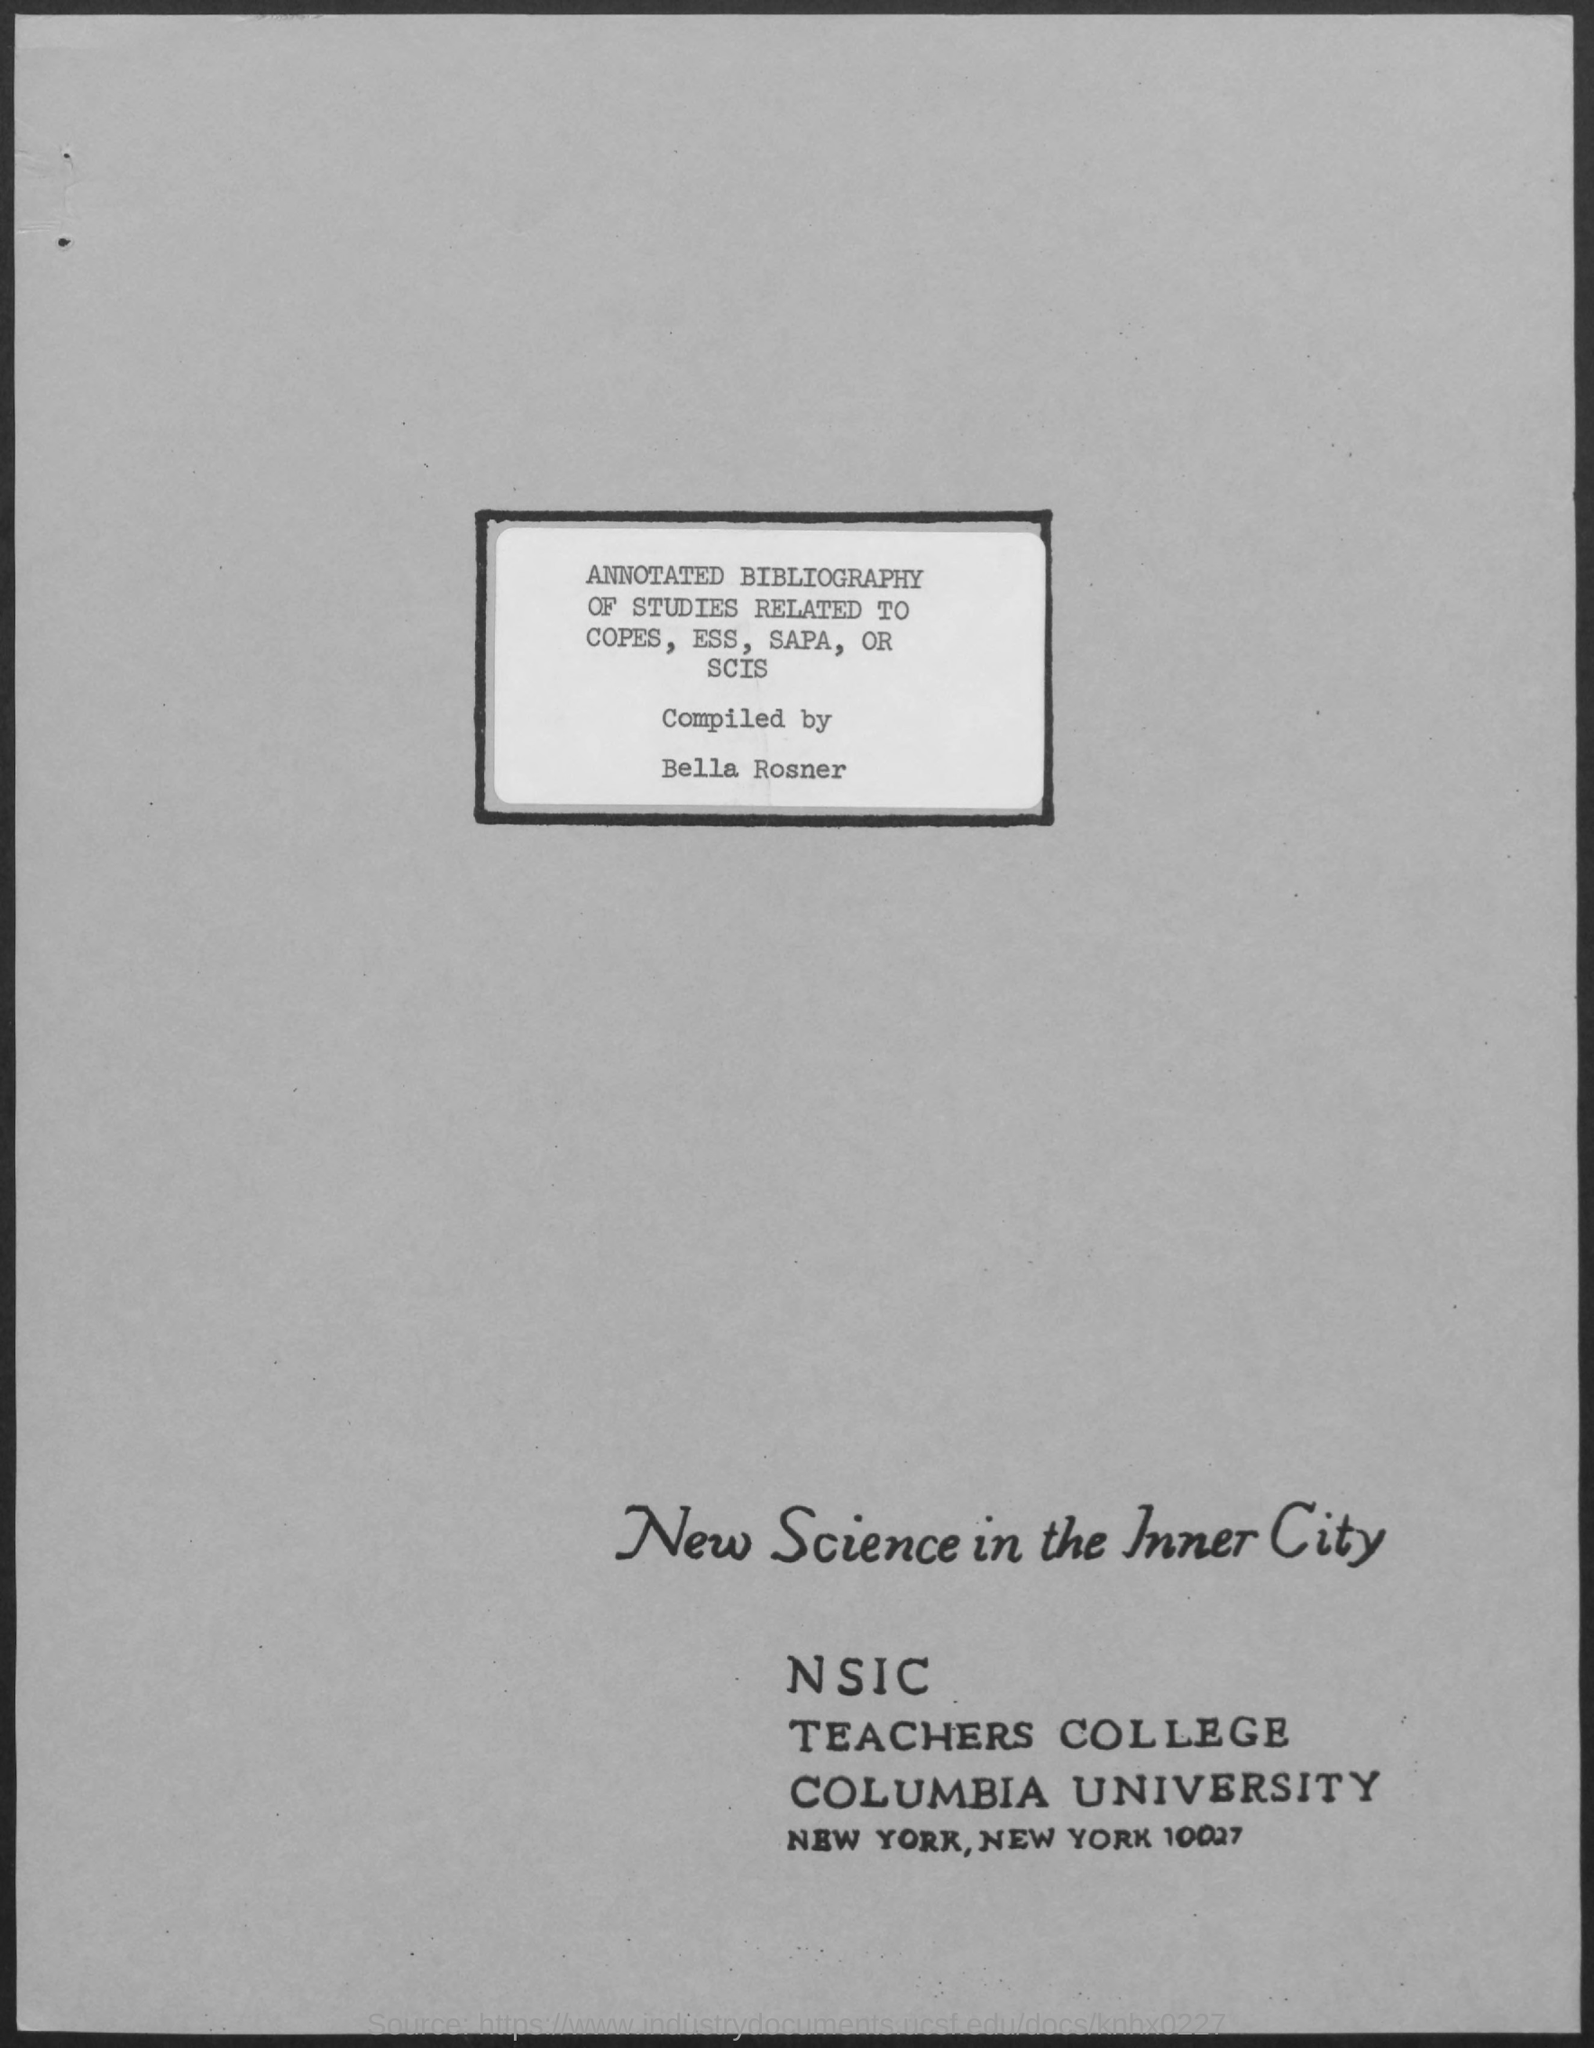Who compiled the annotated Bibliography?
Provide a short and direct response. Bella Rosner. What does NSIC stand for?
Your response must be concise. New Science in the Inner City. 